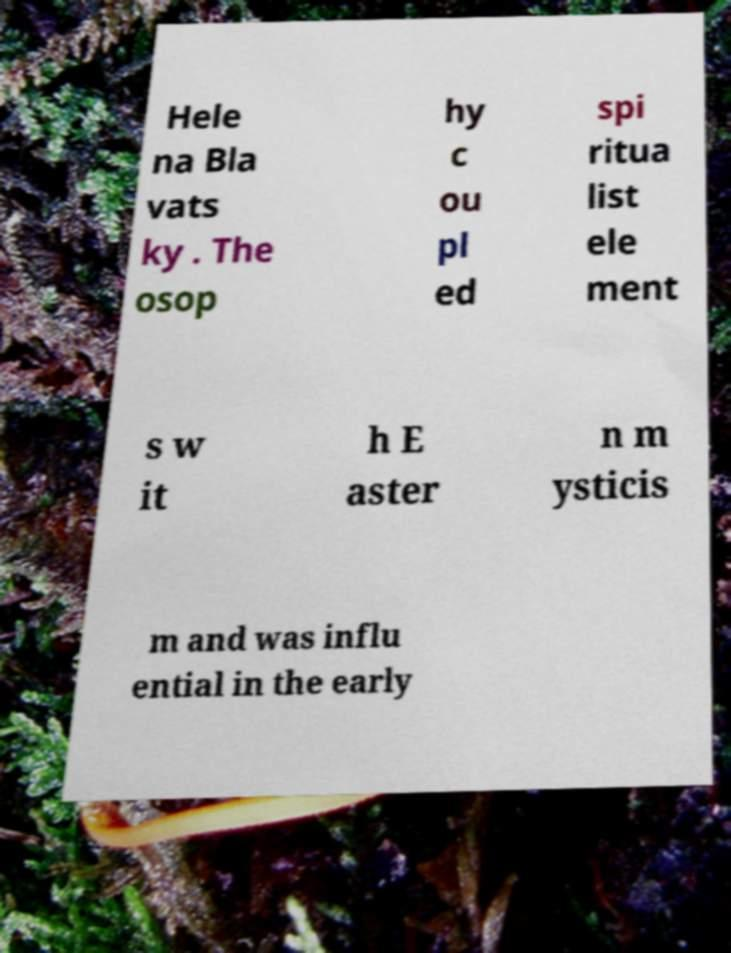Could you assist in decoding the text presented in this image and type it out clearly? Hele na Bla vats ky . The osop hy c ou pl ed spi ritua list ele ment s w it h E aster n m ysticis m and was influ ential in the early 